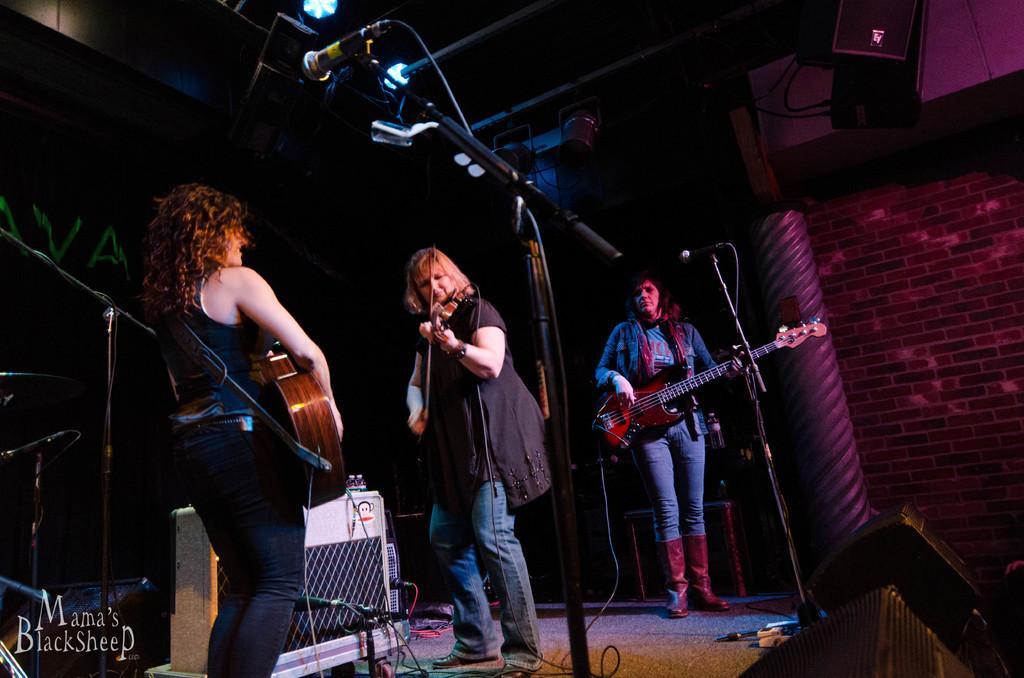In one or two sentences, can you explain what this image depicts? This is a picture taken on a stage, there are three persons holding a music instrument in front of these people there are microphone with stand. Behind the people there are music instruments and a wall. 